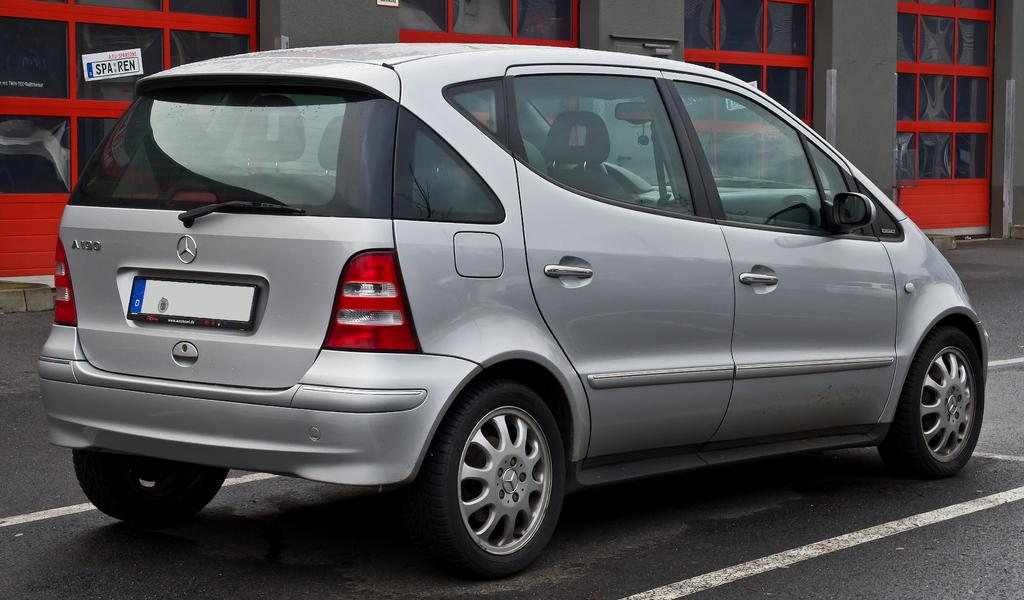What is the main subject in the front of the image? There is a car in the front of the image. What can be seen in the background of the image? There are glasses in the background of the image. Can you describe the paper in the image? A paper is pasted to a glass on the left side of the image. What type of school is depicted in the image? There is no school present in the image; it features a car, glasses, and a paper pasted to a glass. What religious symbols can be seen in the image? There are no religious symbols present in the image. 